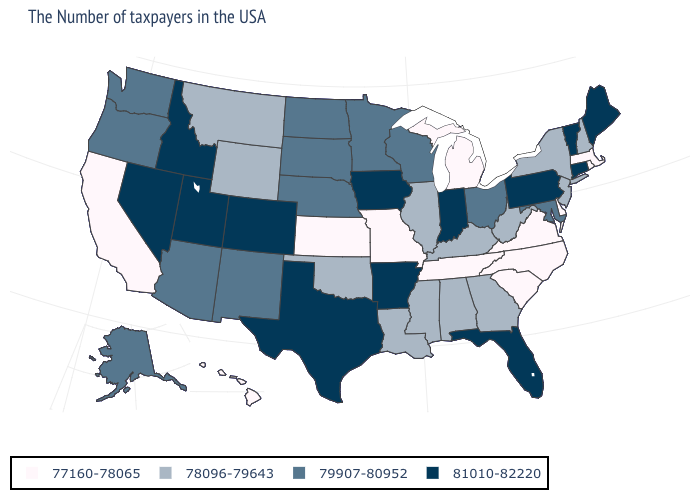What is the lowest value in the South?
Quick response, please. 77160-78065. What is the value of North Dakota?
Be succinct. 79907-80952. Among the states that border Vermont , which have the lowest value?
Answer briefly. Massachusetts. What is the value of Georgia?
Quick response, please. 78096-79643. Does Rhode Island have the same value as Montana?
Be succinct. No. Name the states that have a value in the range 77160-78065?
Short answer required. Massachusetts, Rhode Island, Delaware, Virginia, North Carolina, South Carolina, Michigan, Tennessee, Missouri, Kansas, California, Hawaii. Among the states that border North Dakota , does South Dakota have the highest value?
Be succinct. Yes. Among the states that border Vermont , does New Hampshire have the lowest value?
Concise answer only. No. Name the states that have a value in the range 77160-78065?
Give a very brief answer. Massachusetts, Rhode Island, Delaware, Virginia, North Carolina, South Carolina, Michigan, Tennessee, Missouri, Kansas, California, Hawaii. Name the states that have a value in the range 81010-82220?
Write a very short answer. Maine, Vermont, Connecticut, Pennsylvania, Florida, Indiana, Arkansas, Iowa, Texas, Colorado, Utah, Idaho, Nevada. Is the legend a continuous bar?
Short answer required. No. Name the states that have a value in the range 77160-78065?
Give a very brief answer. Massachusetts, Rhode Island, Delaware, Virginia, North Carolina, South Carolina, Michigan, Tennessee, Missouri, Kansas, California, Hawaii. How many symbols are there in the legend?
Write a very short answer. 4. Does Alaska have the same value as New Hampshire?
Be succinct. No. Among the states that border Michigan , which have the highest value?
Concise answer only. Indiana. 